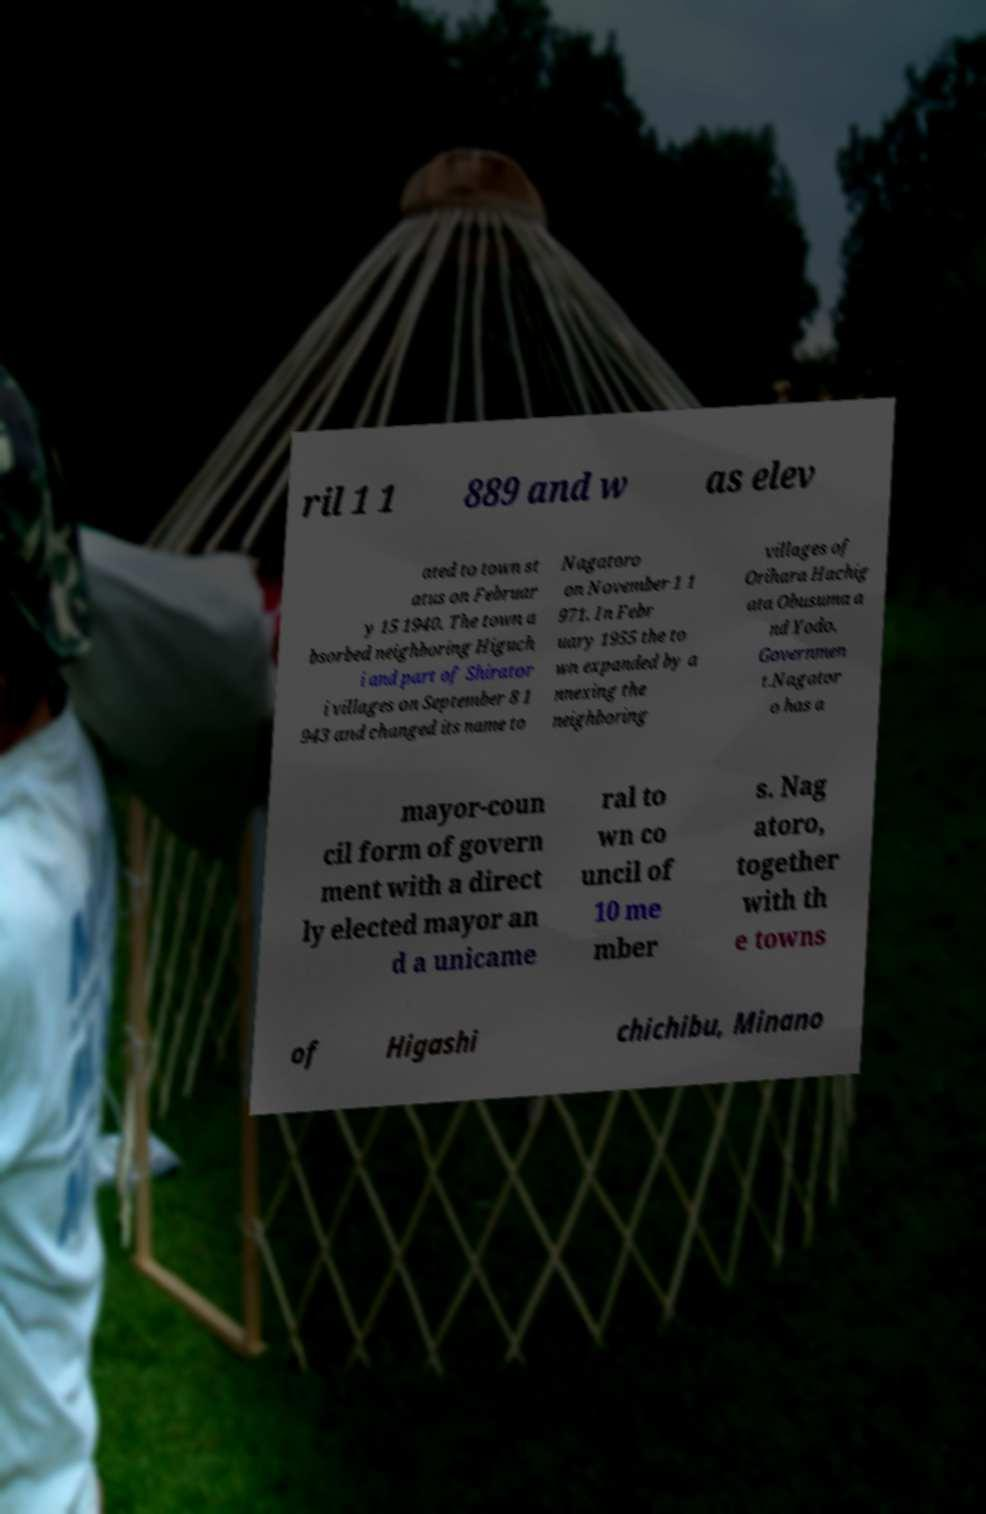Please read and relay the text visible in this image. What does it say? ril 1 1 889 and w as elev ated to town st atus on Februar y 15 1940. The town a bsorbed neighboring Higuch i and part of Shirator i villages on September 8 1 943 and changed its name to Nagatoro on November 1 1 971. In Febr uary 1955 the to wn expanded by a nnexing the neighboring villages of Orihara Hachig ata Obusuma a nd Yodo. Governmen t.Nagator o has a mayor-coun cil form of govern ment with a direct ly elected mayor an d a unicame ral to wn co uncil of 10 me mber s. Nag atoro, together with th e towns of Higashi chichibu, Minano 